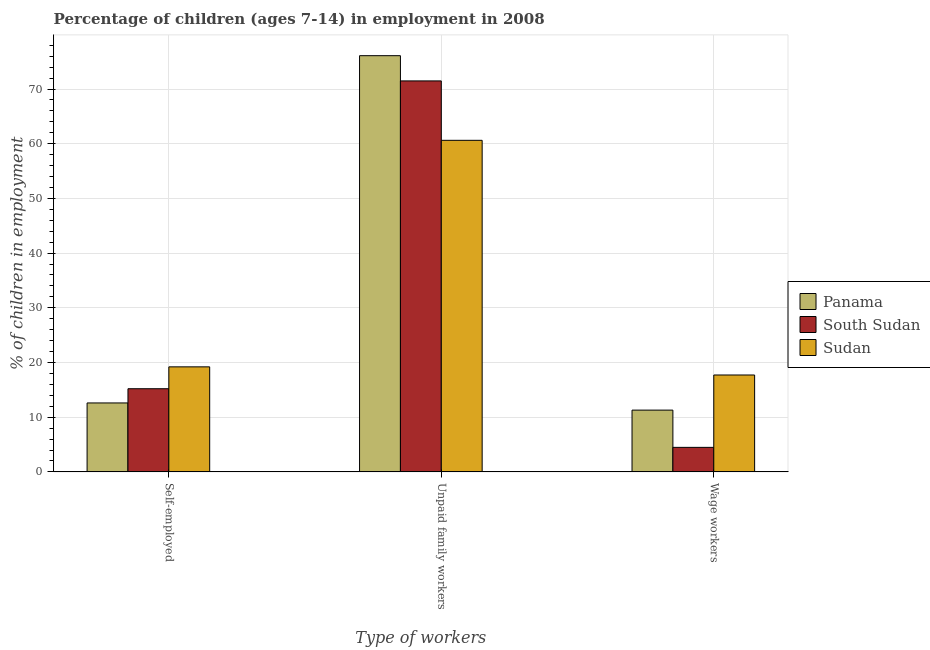How many different coloured bars are there?
Ensure brevity in your answer.  3. Are the number of bars per tick equal to the number of legend labels?
Your answer should be very brief. Yes. Are the number of bars on each tick of the X-axis equal?
Your answer should be very brief. Yes. How many bars are there on the 1st tick from the right?
Offer a terse response. 3. What is the label of the 2nd group of bars from the left?
Make the answer very short. Unpaid family workers. What is the percentage of self employed children in South Sudan?
Your response must be concise. 15.21. Across all countries, what is the maximum percentage of children employed as unpaid family workers?
Make the answer very short. 76.09. Across all countries, what is the minimum percentage of self employed children?
Your answer should be very brief. 12.61. In which country was the percentage of self employed children maximum?
Offer a terse response. Sudan. In which country was the percentage of self employed children minimum?
Offer a very short reply. Panama. What is the total percentage of children employed as unpaid family workers in the graph?
Your response must be concise. 208.19. What is the difference between the percentage of children employed as unpaid family workers in South Sudan and that in Panama?
Offer a very short reply. -4.61. What is the difference between the percentage of children employed as wage workers in South Sudan and the percentage of children employed as unpaid family workers in Panama?
Your answer should be very brief. -71.6. What is the average percentage of children employed as wage workers per country?
Offer a very short reply. 11.17. What is the difference between the percentage of children employed as unpaid family workers and percentage of children employed as wage workers in Panama?
Give a very brief answer. 64.79. In how many countries, is the percentage of children employed as wage workers greater than 44 %?
Provide a succinct answer. 0. What is the ratio of the percentage of children employed as unpaid family workers in Panama to that in Sudan?
Offer a very short reply. 1.26. Is the difference between the percentage of children employed as unpaid family workers in Sudan and Panama greater than the difference between the percentage of children employed as wage workers in Sudan and Panama?
Offer a terse response. No. What is the difference between the highest and the second highest percentage of self employed children?
Keep it short and to the point. 4. What is the difference between the highest and the lowest percentage of children employed as wage workers?
Offer a terse response. 13.23. In how many countries, is the percentage of children employed as unpaid family workers greater than the average percentage of children employed as unpaid family workers taken over all countries?
Your answer should be compact. 2. Is the sum of the percentage of children employed as unpaid family workers in South Sudan and Panama greater than the maximum percentage of children employed as wage workers across all countries?
Provide a short and direct response. Yes. What does the 3rd bar from the left in Wage workers represents?
Your answer should be compact. Sudan. What does the 3rd bar from the right in Self-employed represents?
Make the answer very short. Panama. Is it the case that in every country, the sum of the percentage of self employed children and percentage of children employed as unpaid family workers is greater than the percentage of children employed as wage workers?
Ensure brevity in your answer.  Yes. How many bars are there?
Make the answer very short. 9. How many countries are there in the graph?
Your answer should be very brief. 3. Does the graph contain any zero values?
Make the answer very short. No. Where does the legend appear in the graph?
Offer a terse response. Center right. What is the title of the graph?
Ensure brevity in your answer.  Percentage of children (ages 7-14) in employment in 2008. Does "Guinea" appear as one of the legend labels in the graph?
Ensure brevity in your answer.  No. What is the label or title of the X-axis?
Keep it short and to the point. Type of workers. What is the label or title of the Y-axis?
Provide a short and direct response. % of children in employment. What is the % of children in employment in Panama in Self-employed?
Your answer should be compact. 12.61. What is the % of children in employment of South Sudan in Self-employed?
Offer a very short reply. 15.21. What is the % of children in employment in Sudan in Self-employed?
Provide a short and direct response. 19.21. What is the % of children in employment of Panama in Unpaid family workers?
Make the answer very short. 76.09. What is the % of children in employment of South Sudan in Unpaid family workers?
Keep it short and to the point. 71.48. What is the % of children in employment in Sudan in Unpaid family workers?
Provide a succinct answer. 60.62. What is the % of children in employment in Panama in Wage workers?
Provide a succinct answer. 11.3. What is the % of children in employment in South Sudan in Wage workers?
Offer a very short reply. 4.49. What is the % of children in employment in Sudan in Wage workers?
Keep it short and to the point. 17.72. Across all Type of workers, what is the maximum % of children in employment of Panama?
Your response must be concise. 76.09. Across all Type of workers, what is the maximum % of children in employment in South Sudan?
Offer a terse response. 71.48. Across all Type of workers, what is the maximum % of children in employment of Sudan?
Keep it short and to the point. 60.62. Across all Type of workers, what is the minimum % of children in employment of South Sudan?
Offer a very short reply. 4.49. Across all Type of workers, what is the minimum % of children in employment of Sudan?
Your answer should be compact. 17.72. What is the total % of children in employment of South Sudan in the graph?
Keep it short and to the point. 91.18. What is the total % of children in employment of Sudan in the graph?
Provide a succinct answer. 97.55. What is the difference between the % of children in employment of Panama in Self-employed and that in Unpaid family workers?
Ensure brevity in your answer.  -63.48. What is the difference between the % of children in employment of South Sudan in Self-employed and that in Unpaid family workers?
Ensure brevity in your answer.  -56.27. What is the difference between the % of children in employment of Sudan in Self-employed and that in Unpaid family workers?
Your answer should be compact. -41.41. What is the difference between the % of children in employment of Panama in Self-employed and that in Wage workers?
Provide a succinct answer. 1.31. What is the difference between the % of children in employment of South Sudan in Self-employed and that in Wage workers?
Offer a very short reply. 10.72. What is the difference between the % of children in employment in Sudan in Self-employed and that in Wage workers?
Ensure brevity in your answer.  1.49. What is the difference between the % of children in employment in Panama in Unpaid family workers and that in Wage workers?
Your answer should be very brief. 64.79. What is the difference between the % of children in employment in South Sudan in Unpaid family workers and that in Wage workers?
Offer a very short reply. 66.99. What is the difference between the % of children in employment in Sudan in Unpaid family workers and that in Wage workers?
Ensure brevity in your answer.  42.9. What is the difference between the % of children in employment in Panama in Self-employed and the % of children in employment in South Sudan in Unpaid family workers?
Give a very brief answer. -58.87. What is the difference between the % of children in employment in Panama in Self-employed and the % of children in employment in Sudan in Unpaid family workers?
Make the answer very short. -48.01. What is the difference between the % of children in employment in South Sudan in Self-employed and the % of children in employment in Sudan in Unpaid family workers?
Give a very brief answer. -45.41. What is the difference between the % of children in employment in Panama in Self-employed and the % of children in employment in South Sudan in Wage workers?
Your answer should be very brief. 8.12. What is the difference between the % of children in employment in Panama in Self-employed and the % of children in employment in Sudan in Wage workers?
Provide a short and direct response. -5.11. What is the difference between the % of children in employment in South Sudan in Self-employed and the % of children in employment in Sudan in Wage workers?
Provide a short and direct response. -2.51. What is the difference between the % of children in employment of Panama in Unpaid family workers and the % of children in employment of South Sudan in Wage workers?
Your answer should be very brief. 71.6. What is the difference between the % of children in employment of Panama in Unpaid family workers and the % of children in employment of Sudan in Wage workers?
Give a very brief answer. 58.37. What is the difference between the % of children in employment in South Sudan in Unpaid family workers and the % of children in employment in Sudan in Wage workers?
Make the answer very short. 53.76. What is the average % of children in employment of Panama per Type of workers?
Keep it short and to the point. 33.33. What is the average % of children in employment of South Sudan per Type of workers?
Give a very brief answer. 30.39. What is the average % of children in employment in Sudan per Type of workers?
Offer a terse response. 32.52. What is the difference between the % of children in employment in Panama and % of children in employment in South Sudan in Unpaid family workers?
Provide a succinct answer. 4.61. What is the difference between the % of children in employment of Panama and % of children in employment of Sudan in Unpaid family workers?
Provide a succinct answer. 15.47. What is the difference between the % of children in employment of South Sudan and % of children in employment of Sudan in Unpaid family workers?
Your answer should be very brief. 10.86. What is the difference between the % of children in employment in Panama and % of children in employment in South Sudan in Wage workers?
Give a very brief answer. 6.81. What is the difference between the % of children in employment in Panama and % of children in employment in Sudan in Wage workers?
Offer a very short reply. -6.42. What is the difference between the % of children in employment in South Sudan and % of children in employment in Sudan in Wage workers?
Give a very brief answer. -13.23. What is the ratio of the % of children in employment of Panama in Self-employed to that in Unpaid family workers?
Offer a very short reply. 0.17. What is the ratio of the % of children in employment of South Sudan in Self-employed to that in Unpaid family workers?
Provide a short and direct response. 0.21. What is the ratio of the % of children in employment of Sudan in Self-employed to that in Unpaid family workers?
Make the answer very short. 0.32. What is the ratio of the % of children in employment in Panama in Self-employed to that in Wage workers?
Provide a short and direct response. 1.12. What is the ratio of the % of children in employment in South Sudan in Self-employed to that in Wage workers?
Provide a succinct answer. 3.39. What is the ratio of the % of children in employment of Sudan in Self-employed to that in Wage workers?
Give a very brief answer. 1.08. What is the ratio of the % of children in employment of Panama in Unpaid family workers to that in Wage workers?
Give a very brief answer. 6.73. What is the ratio of the % of children in employment of South Sudan in Unpaid family workers to that in Wage workers?
Your answer should be compact. 15.92. What is the ratio of the % of children in employment of Sudan in Unpaid family workers to that in Wage workers?
Your response must be concise. 3.42. What is the difference between the highest and the second highest % of children in employment of Panama?
Provide a short and direct response. 63.48. What is the difference between the highest and the second highest % of children in employment in South Sudan?
Keep it short and to the point. 56.27. What is the difference between the highest and the second highest % of children in employment of Sudan?
Your answer should be compact. 41.41. What is the difference between the highest and the lowest % of children in employment of Panama?
Ensure brevity in your answer.  64.79. What is the difference between the highest and the lowest % of children in employment in South Sudan?
Provide a succinct answer. 66.99. What is the difference between the highest and the lowest % of children in employment in Sudan?
Keep it short and to the point. 42.9. 